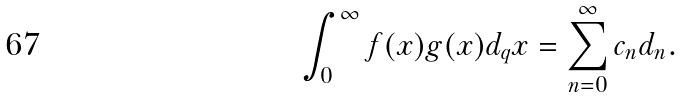<formula> <loc_0><loc_0><loc_500><loc_500>\int _ { 0 } ^ { \infty } f ( x ) g ( x ) d _ { q } x = \sum _ { n = 0 } ^ { \infty } c _ { n } d _ { n } .</formula> 